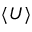<formula> <loc_0><loc_0><loc_500><loc_500>\langle U \rangle</formula> 